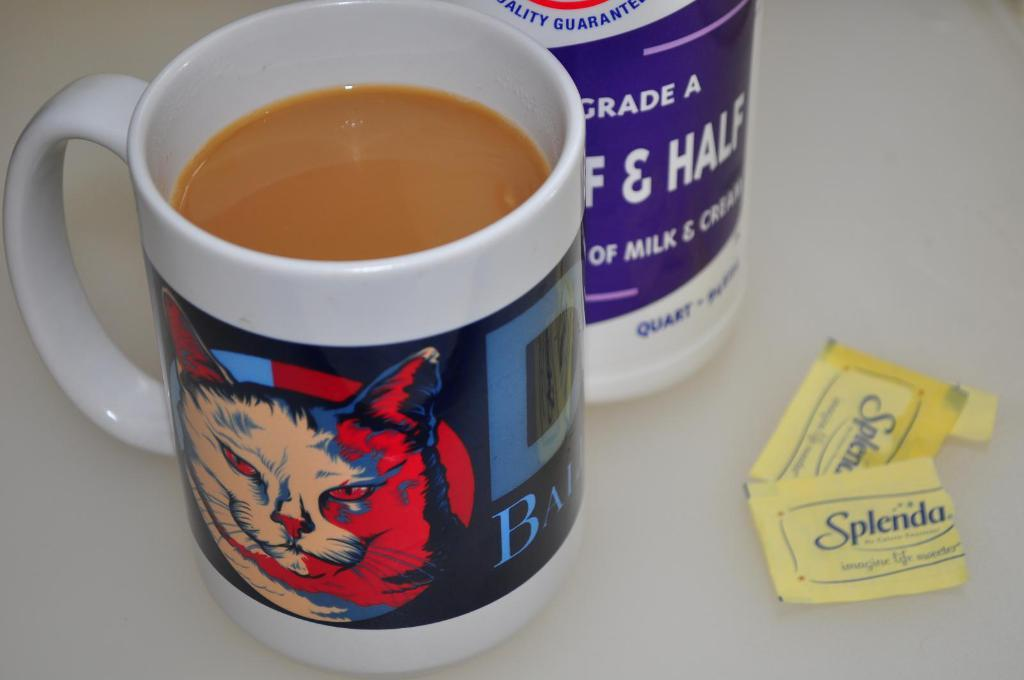<image>
Present a compact description of the photo's key features. Full cup of coffee with a cat on the mug and an open bag of splenda. 